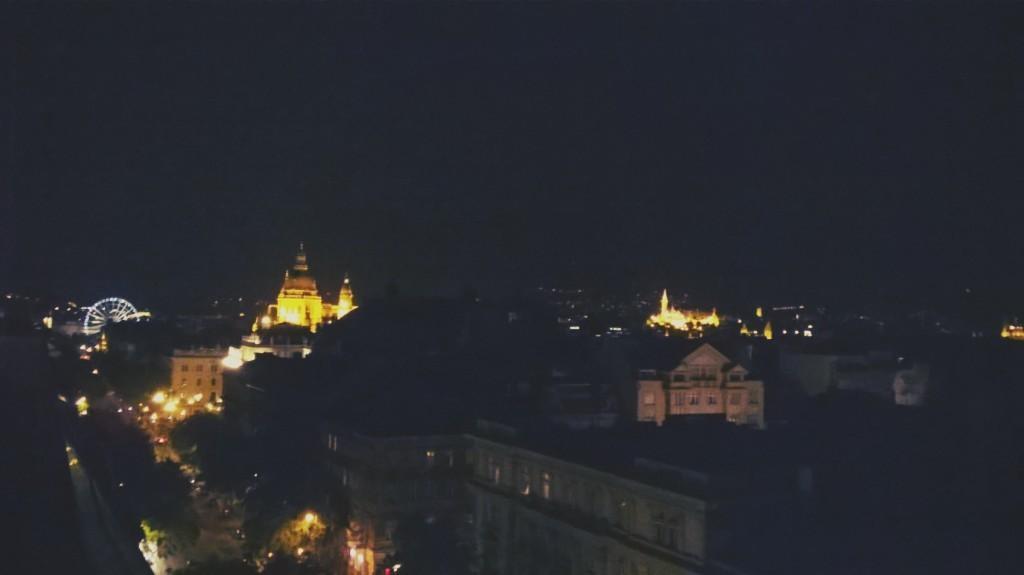Could you give a brief overview of what you see in this image? This picture is dark,we can see trees,buildings and lights. 